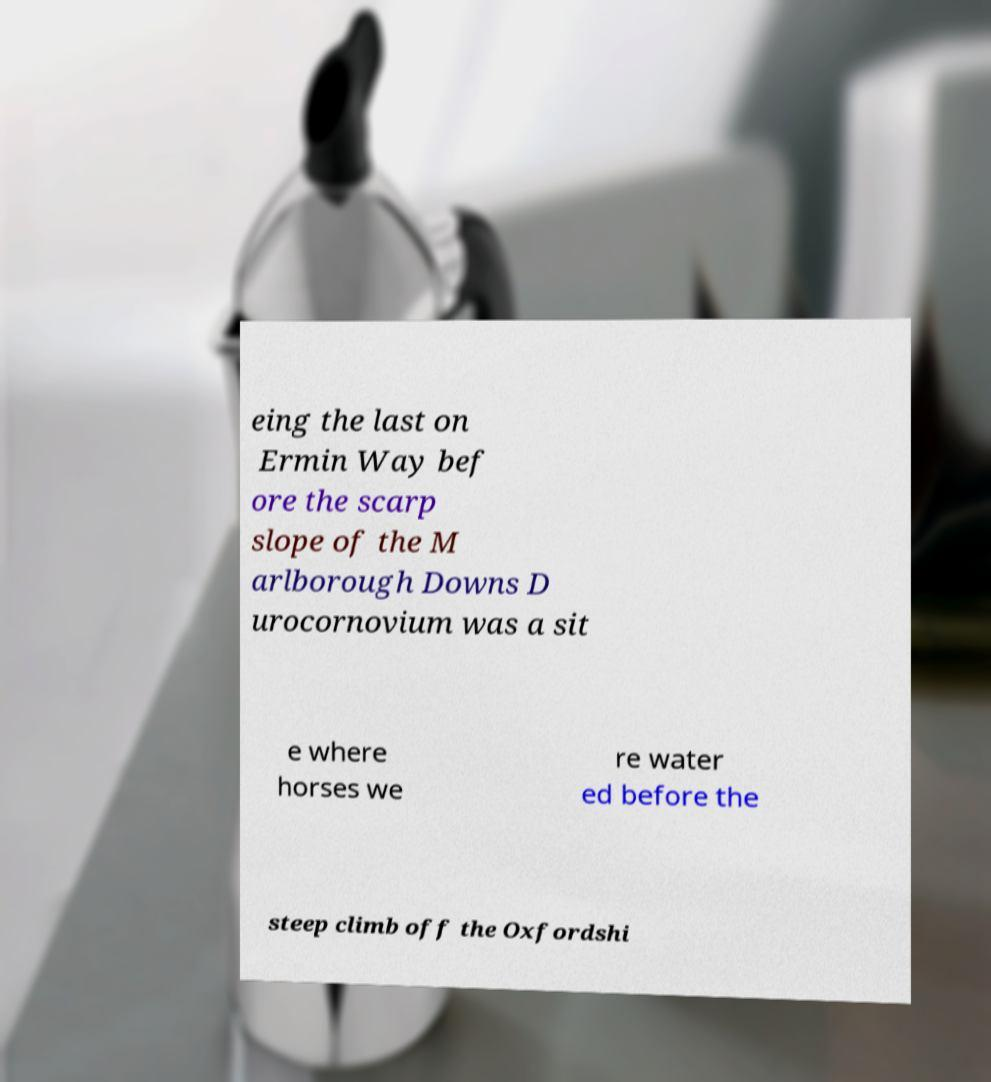Can you read and provide the text displayed in the image?This photo seems to have some interesting text. Can you extract and type it out for me? eing the last on Ermin Way bef ore the scarp slope of the M arlborough Downs D urocornovium was a sit e where horses we re water ed before the steep climb off the Oxfordshi 